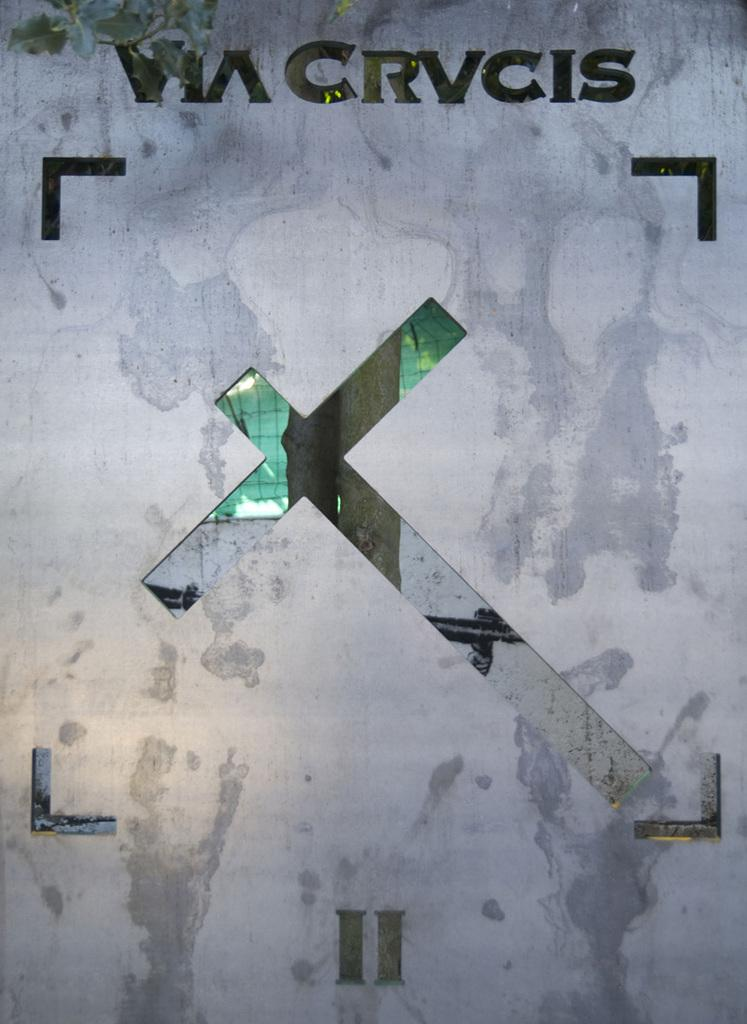<image>
Write a terse but informative summary of the picture. Via Crvcis wrote on a wallpaper with an x in the middle 